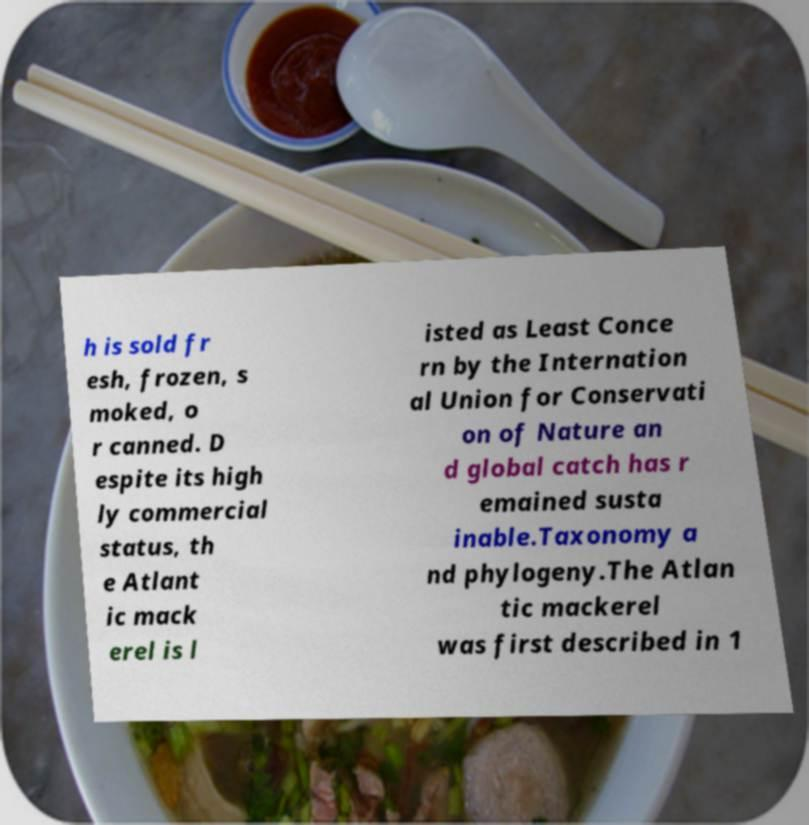Please identify and transcribe the text found in this image. h is sold fr esh, frozen, s moked, o r canned. D espite its high ly commercial status, th e Atlant ic mack erel is l isted as Least Conce rn by the Internation al Union for Conservati on of Nature an d global catch has r emained susta inable.Taxonomy a nd phylogeny.The Atlan tic mackerel was first described in 1 